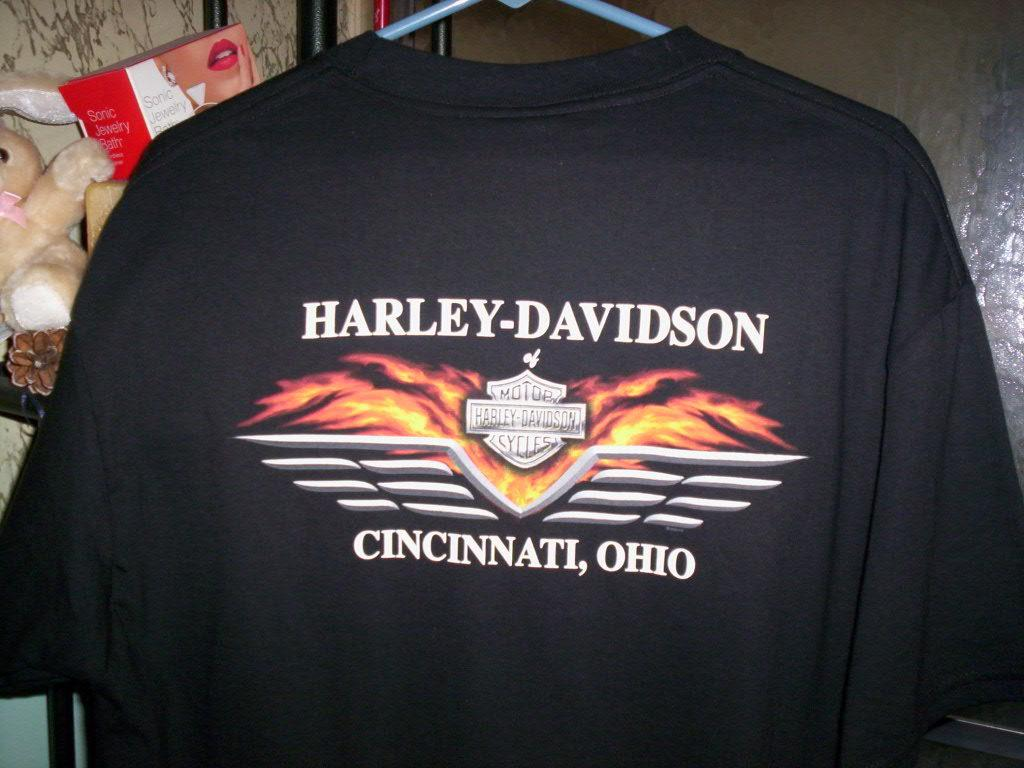<image>
Present a compact description of the photo's key features. A black Harley-Davidson t-shirt hangs on a hanger. 